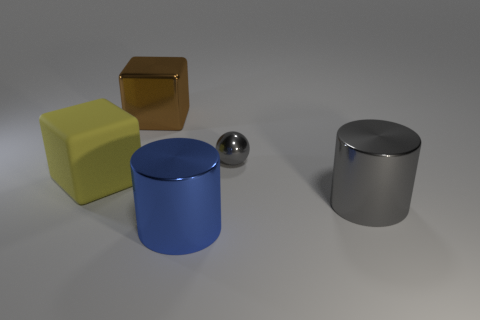Add 1 yellow cubes. How many objects exist? 6 Subtract all spheres. How many objects are left? 4 Add 3 matte things. How many matte things exist? 4 Subtract 0 green spheres. How many objects are left? 5 Subtract all large brown things. Subtract all small blue metal objects. How many objects are left? 4 Add 2 small metal spheres. How many small metal spheres are left? 3 